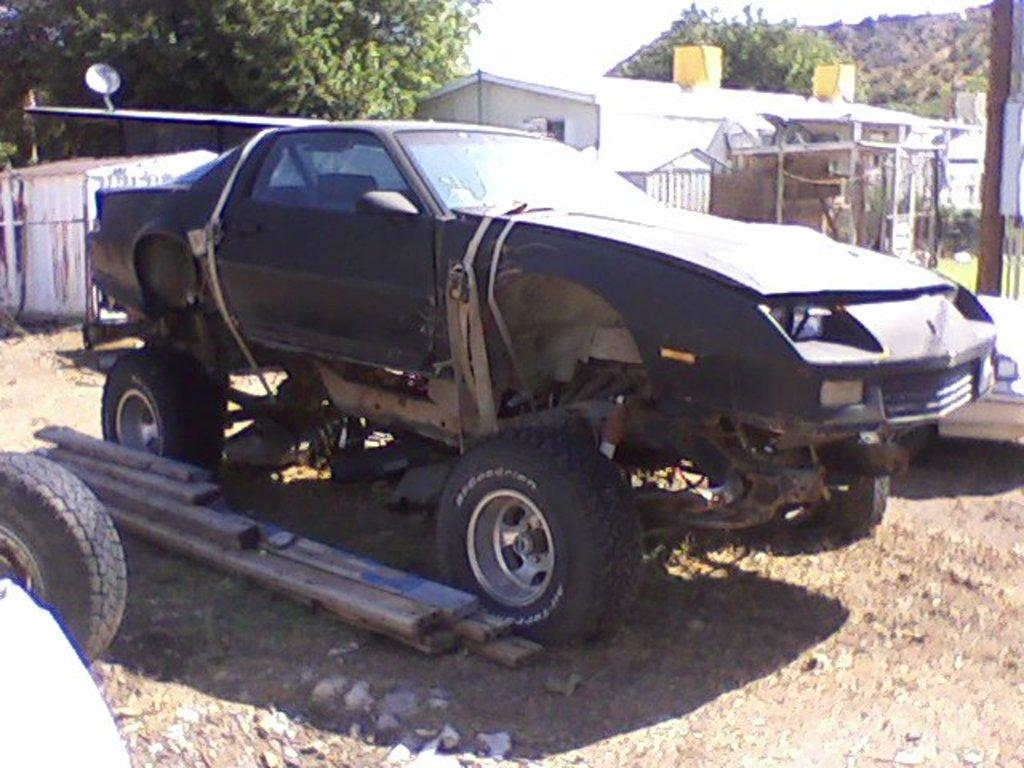What is the main subject of the image? There is a car in the image. Where is the car located? The car is parked on the ground. What can be seen in the background of the image? There are trees and buildings visible in the image. What type of wind can be seen blowing through the car in the image? There is no wind visible in the image, and the car is parked, so it is not moving. 